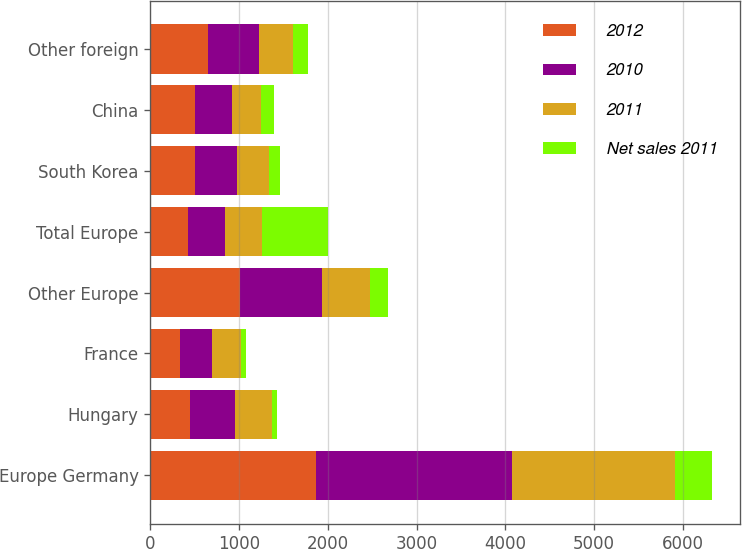Convert chart. <chart><loc_0><loc_0><loc_500><loc_500><stacked_bar_chart><ecel><fcel>Europe Germany<fcel>Hungary<fcel>France<fcel>Other Europe<fcel>Total Europe<fcel>South Korea<fcel>China<fcel>Other foreign<nl><fcel>2012<fcel>1871.3<fcel>448.9<fcel>335.2<fcel>1015.1<fcel>420.4<fcel>505.6<fcel>499.1<fcel>650.8<nl><fcel>2010<fcel>2200<fcel>503.2<fcel>363<fcel>917.8<fcel>420.4<fcel>471.7<fcel>416.6<fcel>568.4<nl><fcel>2011<fcel>1839.9<fcel>418.3<fcel>318.7<fcel>546.1<fcel>420.4<fcel>358<fcel>330.6<fcel>390.1<nl><fcel>Net sales 2011<fcel>420.4<fcel>56.9<fcel>63.2<fcel>194.6<fcel>735.1<fcel>124.5<fcel>148<fcel>164.1<nl></chart> 